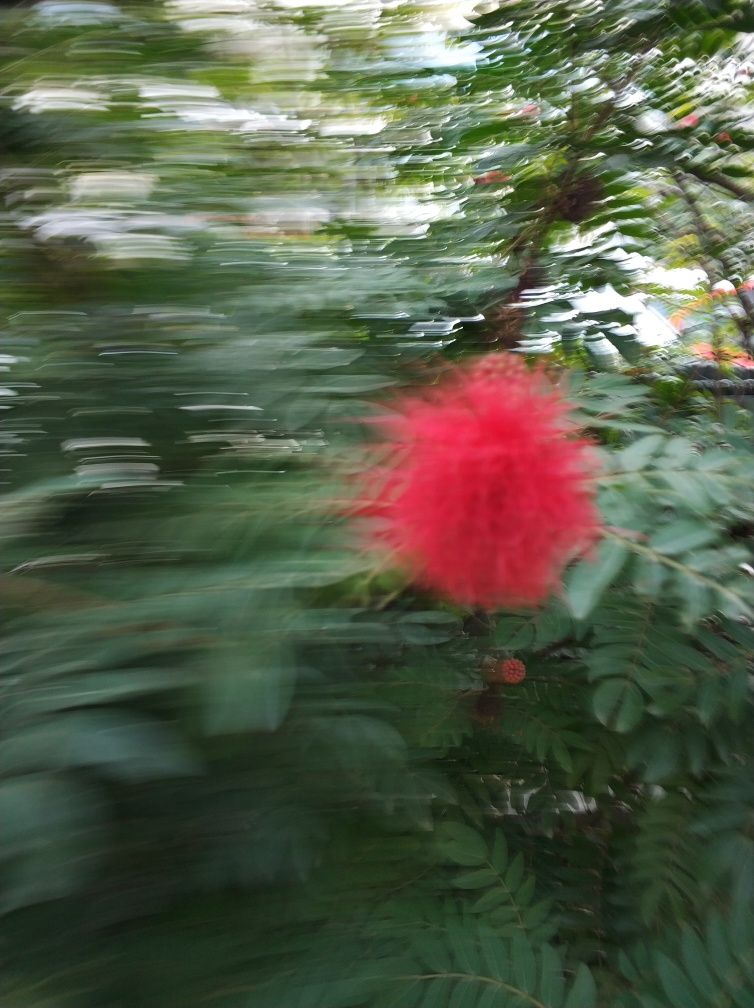What time of day might this photo have been taken? Based on the natural, diffused light quality without harsh shadows, and the overall atmosphere of the image, it's reasonable to infer that the photo may have been taken during the early morning or late afternoon, when the sun provides a softer, more even light. 